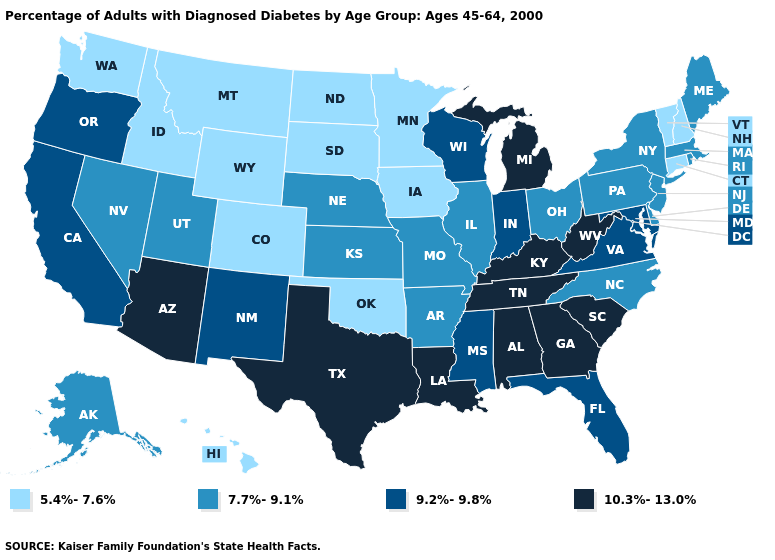Does the map have missing data?
Write a very short answer. No. What is the value of North Dakota?
Keep it brief. 5.4%-7.6%. Among the states that border Utah , which have the highest value?
Quick response, please. Arizona. Which states have the lowest value in the West?
Short answer required. Colorado, Hawaii, Idaho, Montana, Washington, Wyoming. What is the highest value in the MidWest ?
Short answer required. 10.3%-13.0%. What is the lowest value in the USA?
Quick response, please. 5.4%-7.6%. What is the highest value in the USA?
Keep it brief. 10.3%-13.0%. Does West Virginia have the same value as Kentucky?
Give a very brief answer. Yes. What is the value of Connecticut?
Give a very brief answer. 5.4%-7.6%. Does Colorado have the lowest value in the USA?
Concise answer only. Yes. Name the states that have a value in the range 9.2%-9.8%?
Short answer required. California, Florida, Indiana, Maryland, Mississippi, New Mexico, Oregon, Virginia, Wisconsin. Name the states that have a value in the range 9.2%-9.8%?
Short answer required. California, Florida, Indiana, Maryland, Mississippi, New Mexico, Oregon, Virginia, Wisconsin. Name the states that have a value in the range 9.2%-9.8%?
Write a very short answer. California, Florida, Indiana, Maryland, Mississippi, New Mexico, Oregon, Virginia, Wisconsin. What is the value of Mississippi?
Short answer required. 9.2%-9.8%. What is the value of Florida?
Be succinct. 9.2%-9.8%. 